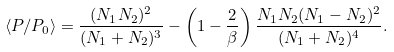Convert formula to latex. <formula><loc_0><loc_0><loc_500><loc_500>\langle P / P _ { 0 } \rangle = \frac { ( N _ { 1 } N _ { 2 } ) ^ { 2 } } { ( N _ { 1 } + N _ { 2 } ) ^ { 3 } } - \left ( 1 - \frac { 2 } { \beta } \right ) \frac { N _ { 1 } N _ { 2 } ( N _ { 1 } - N _ { 2 } ) ^ { 2 } } { ( N _ { 1 } + N _ { 2 } ) ^ { 4 } } .</formula> 